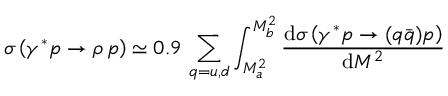<formula> <loc_0><loc_0><loc_500><loc_500>\sigma \left ( \gamma ^ { * } p \to \rho \, p \right ) \simeq 0 . 9 \, \sum _ { q = u , d } \int _ { M _ { a } ^ { 2 } } ^ { M _ { b } ^ { 2 } } \frac { d \sigma \left ( \gamma ^ { * } p \to ( q \bar { q } ) p \right ) } { d M ^ { 2 } }</formula> 